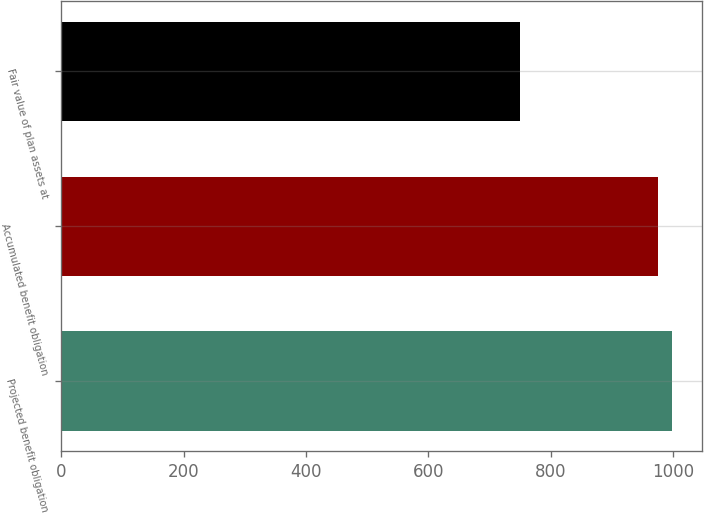Convert chart to OTSL. <chart><loc_0><loc_0><loc_500><loc_500><bar_chart><fcel>Projected benefit obligation<fcel>Accumulated benefit obligation<fcel>Fair value of plan assets at<nl><fcel>997.7<fcel>975<fcel>749<nl></chart> 